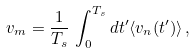Convert formula to latex. <formula><loc_0><loc_0><loc_500><loc_500>v _ { m } = \frac { 1 } { T _ { s } } \, \int _ { 0 } ^ { T _ { s } } d t ^ { \prime } \langle { v } _ { n } ( t ^ { \prime } ) \rangle \, ,</formula> 